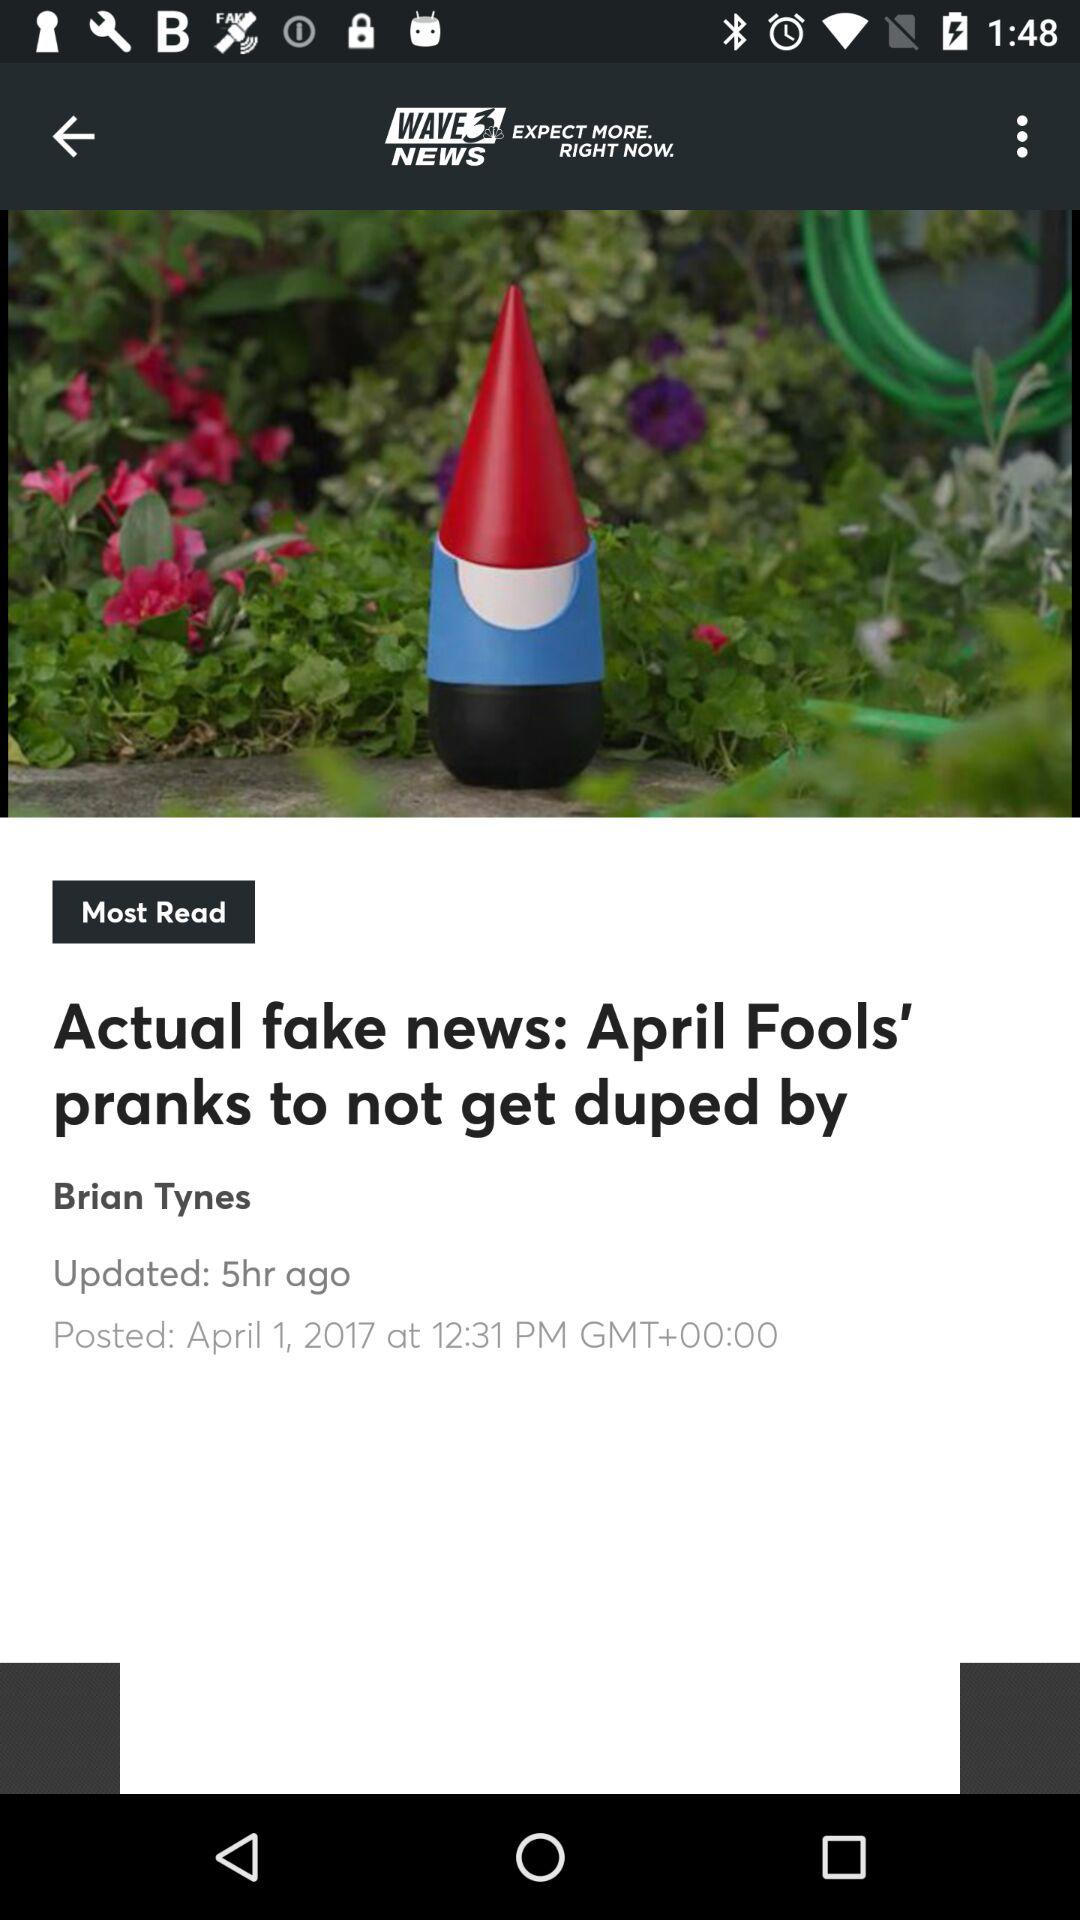When was the article posted? The article was posted on April 1, 2017 at 12:31 PM GMT+00:00. 